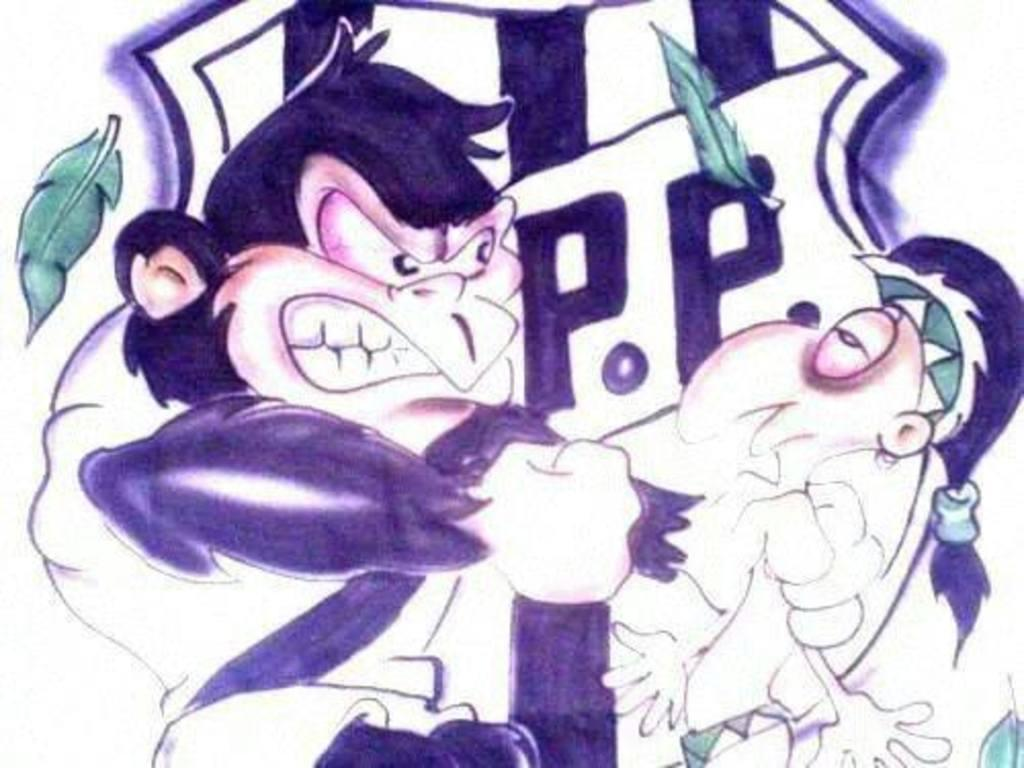What animal is depicted in the image? There is a monkey in the image. What action is the monkey performing in the image? The monkey is punching a human in the image. What type of artwork is the image? The image is a painting. Where is the playground located in the image? There is no playground present in the image. What type of seed is being used by the monkey in the image? There is no seed present in the image. 